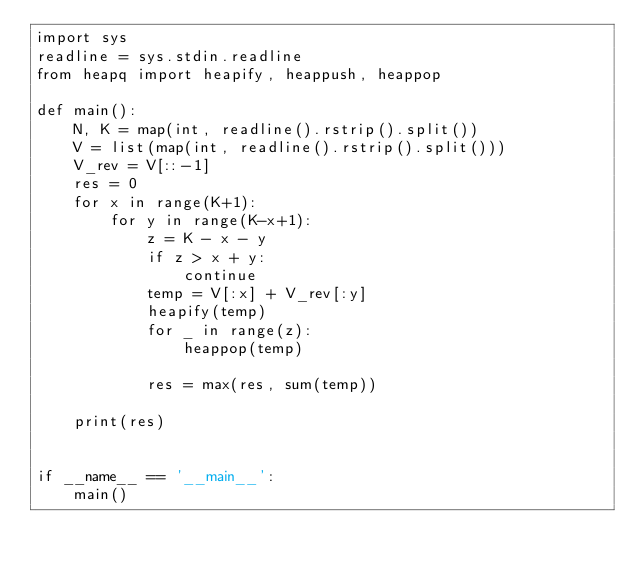<code> <loc_0><loc_0><loc_500><loc_500><_Python_>import sys
readline = sys.stdin.readline
from heapq import heapify, heappush, heappop

def main():
    N, K = map(int, readline().rstrip().split())
    V = list(map(int, readline().rstrip().split()))
    V_rev = V[::-1]
    res = 0
    for x in range(K+1):
        for y in range(K-x+1):
            z = K - x - y
            if z > x + y:
                continue
            temp = V[:x] + V_rev[:y]
            heapify(temp)
            for _ in range(z):
                heappop(temp)

            res = max(res, sum(temp))
    
    print(res)


if __name__ == '__main__':
    main()</code> 